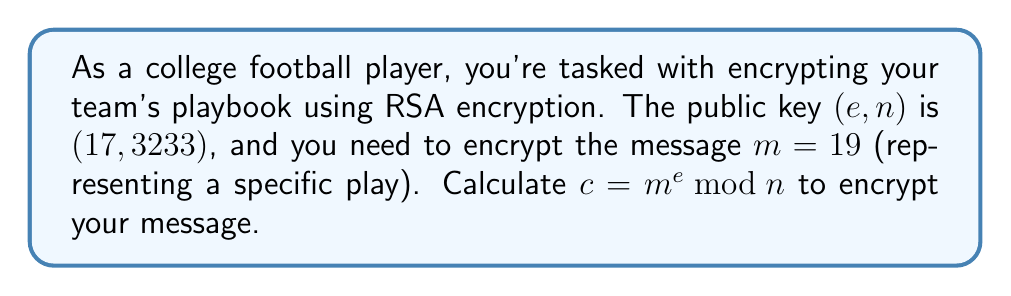Can you solve this math problem? To compute the modular exponentiation for RSA encryption, we need to calculate $c = m^e \bmod n$, where:

$m = 19$ (the message)
$e = 17$ (the public exponent)
$n = 3233$ (the modulus)

We can use the square-and-multiply algorithm to efficiently compute this:

1) Convert the exponent (17) to binary: $17_{10} = 10001_2$

2) Initialize: $result = 1$, $base = 19$

3) For each bit in the binary exponent (from left to right):
   a) Square the result: $result = result^2 \bmod n$
   b) If the bit is 1, multiply by the base: $result = (result \cdot base) \bmod n$

Step-by-step calculation:

1. $result = 1^2 \cdot 19 = 19 \bmod 3233$
2. $result = 19^2 = 361 \bmod 3233$
3. $result = 361^2 = 130321 \equiv 2222 \bmod 3233$
4. $result = 2222^2 = 4937284 \equiv 404 \bmod 3233$
5. $result = 404^2 \cdot 19 = 3096304 \equiv 2081 \bmod 3233$

Therefore, $c = 19^{17} \bmod 3233 = 2081$
Answer: $2081$ 